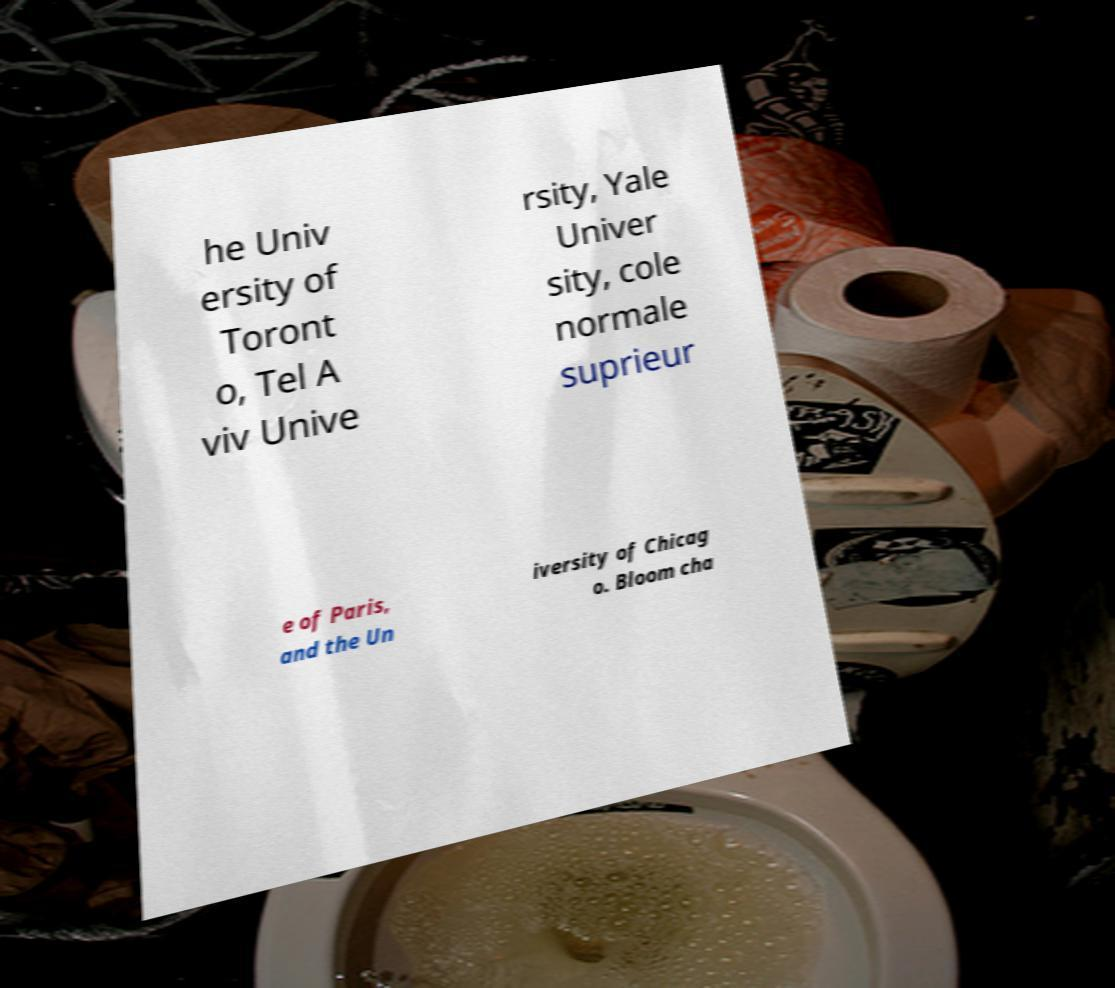Can you read and provide the text displayed in the image?This photo seems to have some interesting text. Can you extract and type it out for me? he Univ ersity of Toront o, Tel A viv Unive rsity, Yale Univer sity, cole normale suprieur e of Paris, and the Un iversity of Chicag o. Bloom cha 